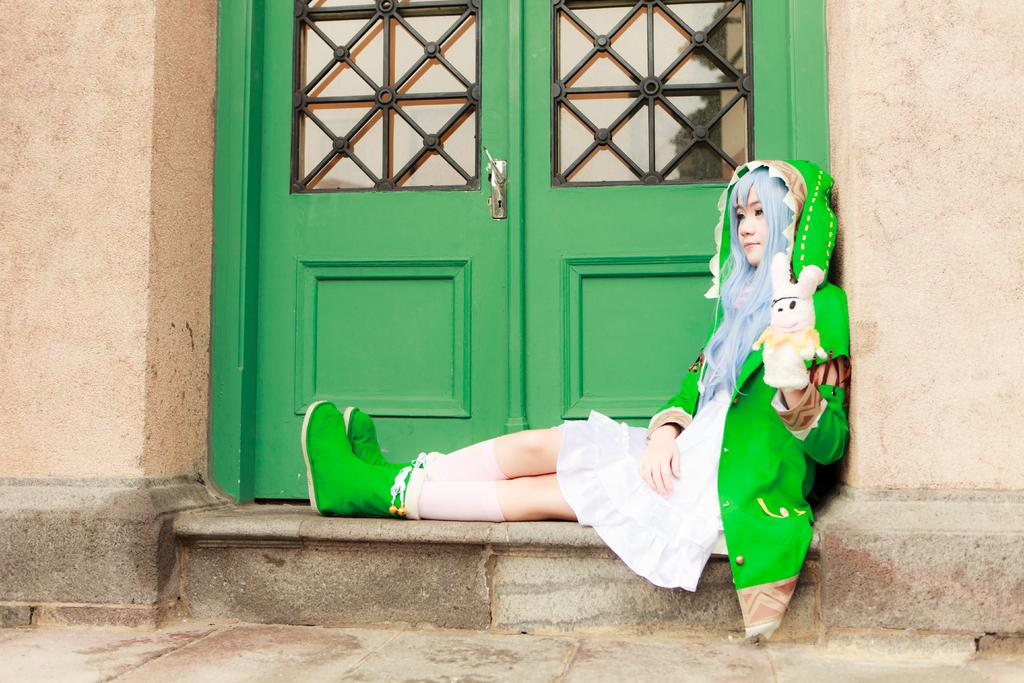What type of surface can be seen in the image? There is ground visible in the image. What color is the building in the image? There is a brown-colored building in the image. What color is the door in the image? There is a green-colored door in the image. What is the person in the image doing? A person is sitting in front of the door. What is the person wearing in the image? The person is wearing a green and white-colored dress. How many rings can be seen on the person's finger in the image? There are no rings visible on the person's finger in the image. What type of clover is growing near the door in the image? There is no clover present in the image. 